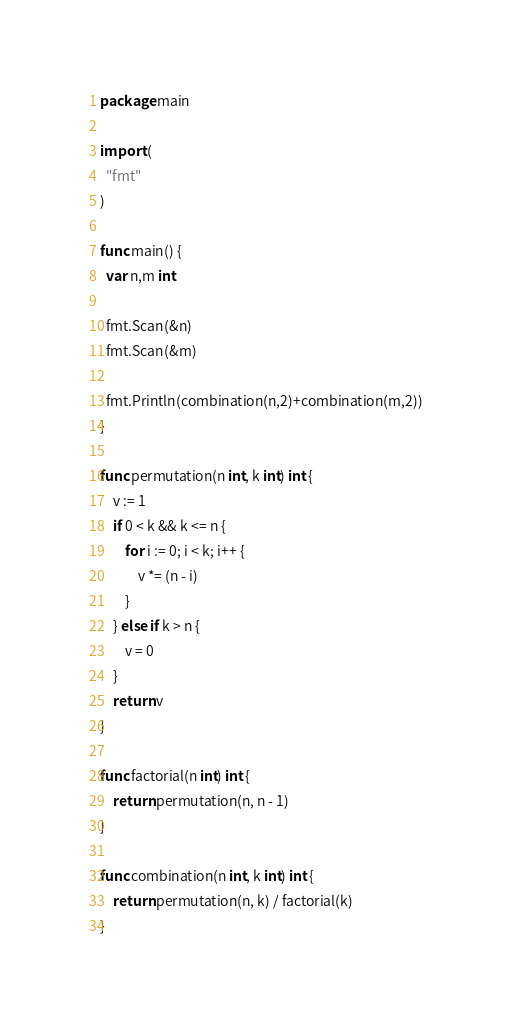<code> <loc_0><loc_0><loc_500><loc_500><_Go_>package main

import (
  "fmt"
)

func main() {
  var n,m int

  fmt.Scan(&n)
  fmt.Scan(&m)

  fmt.Println(combination(n,2)+combination(m,2))
}

func permutation(n int, k int) int {
    v := 1
    if 0 < k && k <= n {
        for i := 0; i < k; i++ {
            v *= (n - i)
        }
    } else if k > n {
        v = 0
    }
    return v
}

func factorial(n int) int {
    return permutation(n, n - 1)
}

func combination(n int, k int) int {
    return permutation(n, k) / factorial(k)
}
</code> 